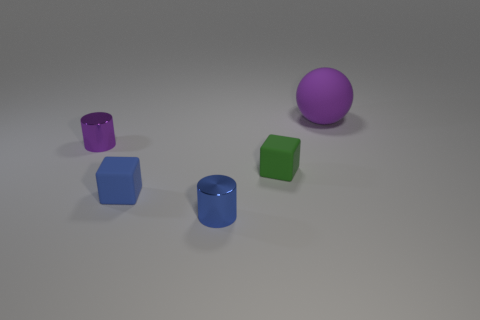Is there any other thing that has the same size as the purple ball?
Ensure brevity in your answer.  No. What number of matte things are either tiny green objects or purple objects?
Keep it short and to the point. 2. What is the size of the other metal thing that is the same color as the large thing?
Keep it short and to the point. Small. What material is the small cylinder left of the tiny shiny cylinder that is on the right side of the purple cylinder?
Your answer should be compact. Metal. How many objects are either tiny purple cylinders or tiny things that are in front of the tiny green matte block?
Your answer should be very brief. 3. What is the size of the blue object that is the same material as the small purple object?
Your answer should be compact. Small. What number of brown objects are tiny things or small shiny objects?
Offer a terse response. 0. Are there any other things that are the same material as the large purple thing?
Offer a very short reply. Yes. There is a purple object that is left of the large purple rubber sphere; is its shape the same as the small thing that is in front of the tiny blue matte thing?
Make the answer very short. Yes. How many gray metallic objects are there?
Keep it short and to the point. 0. 